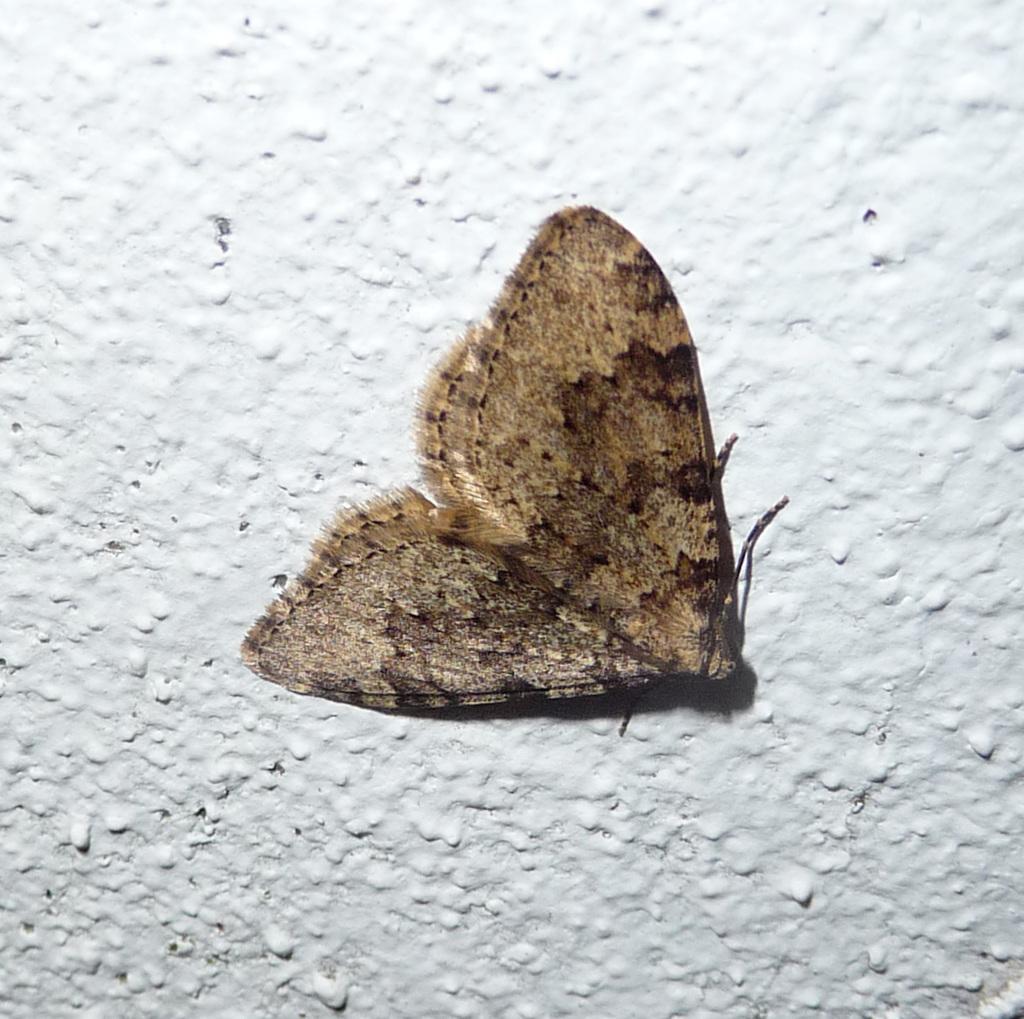In one or two sentences, can you explain what this image depicts? In this image we can see fly on the wall. 